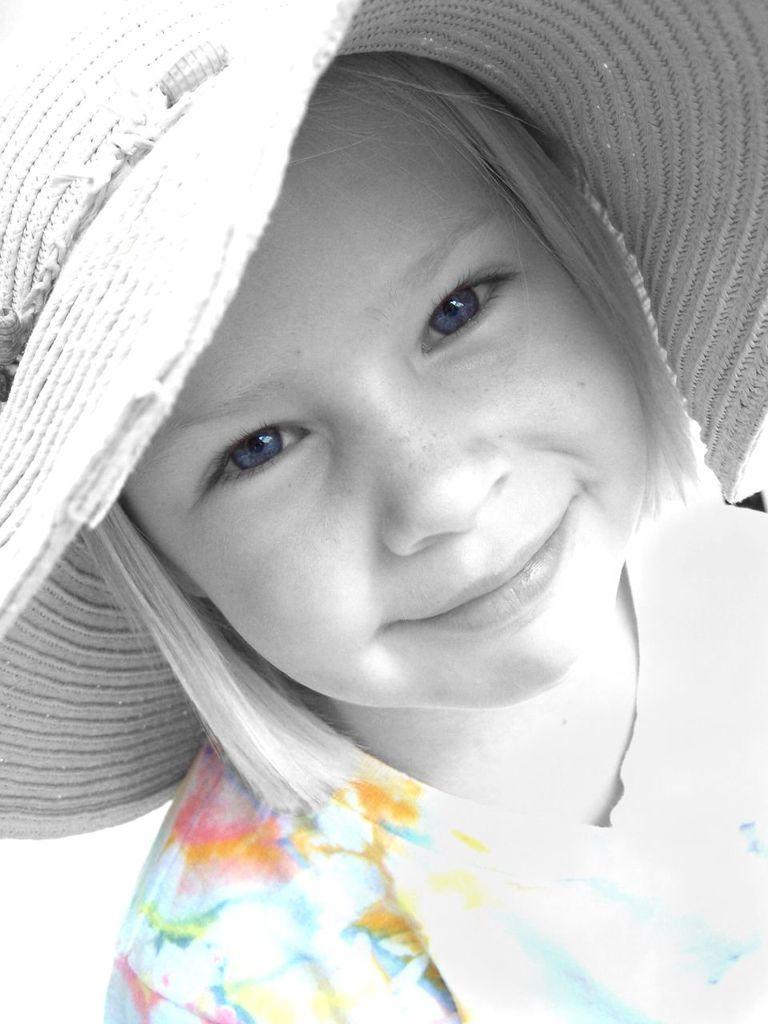In one or two sentences, can you explain what this image depicts? This is an edited image. In this image we can see a girl wearing a hat. 